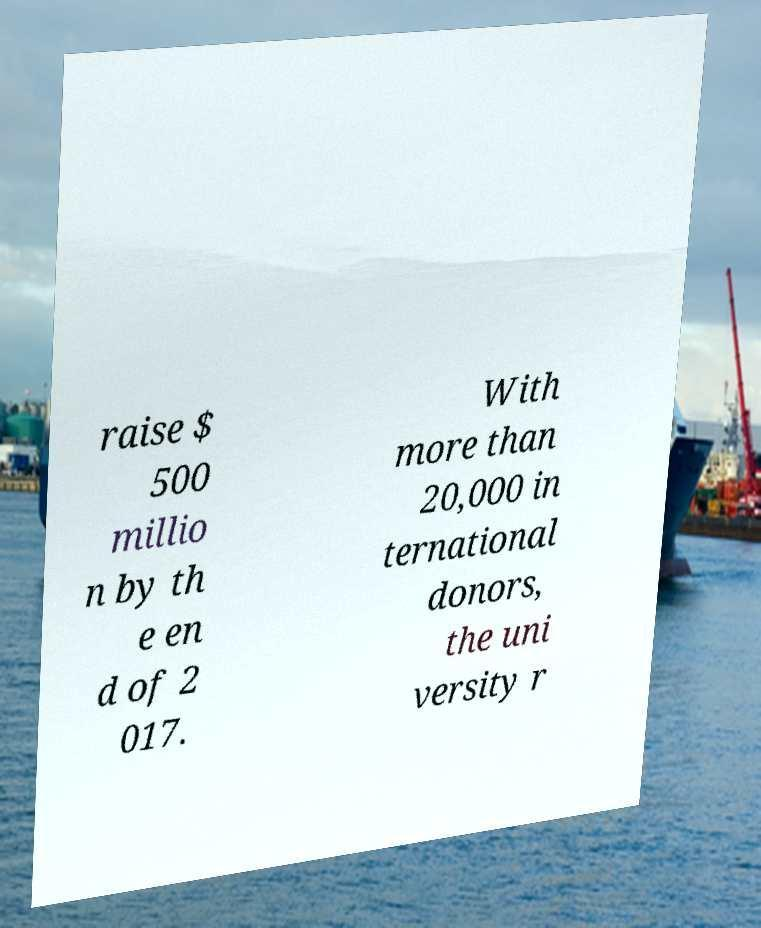Can you read and provide the text displayed in the image?This photo seems to have some interesting text. Can you extract and type it out for me? raise $ 500 millio n by th e en d of 2 017. With more than 20,000 in ternational donors, the uni versity r 